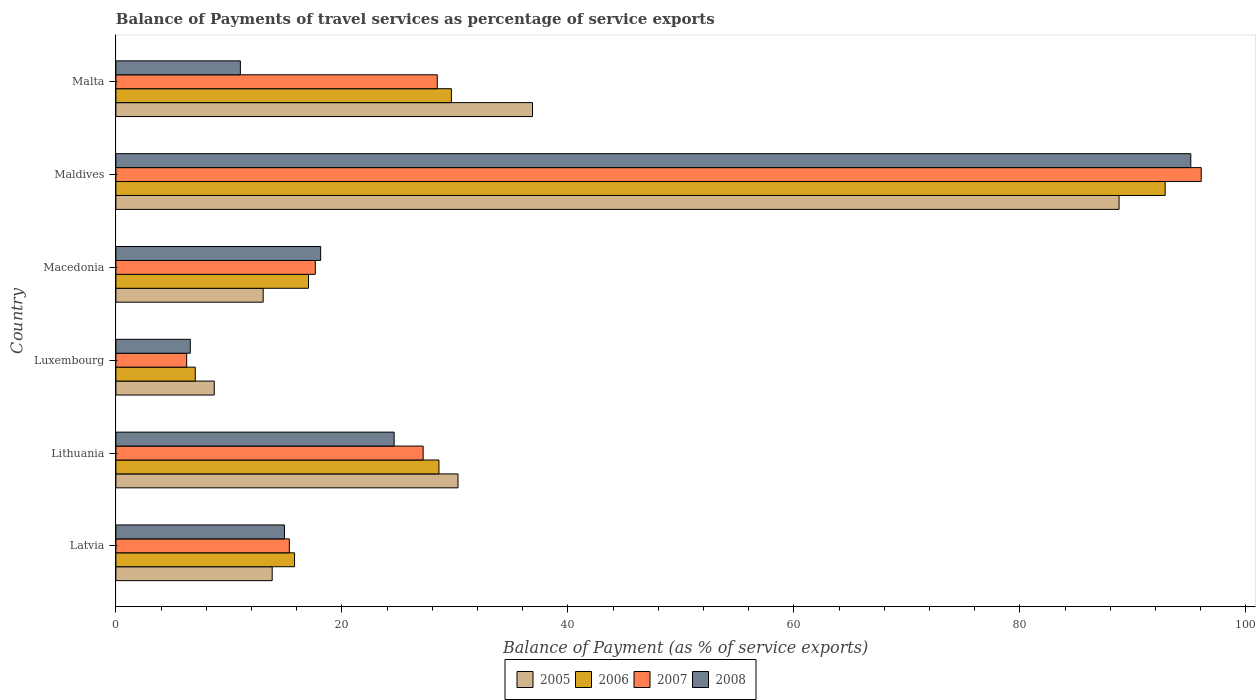What is the label of the 3rd group of bars from the top?
Your answer should be compact. Macedonia. In how many cases, is the number of bars for a given country not equal to the number of legend labels?
Offer a terse response. 0. What is the balance of payments of travel services in 2007 in Malta?
Your response must be concise. 28.44. Across all countries, what is the maximum balance of payments of travel services in 2006?
Offer a very short reply. 92.86. Across all countries, what is the minimum balance of payments of travel services in 2008?
Ensure brevity in your answer.  6.58. In which country was the balance of payments of travel services in 2005 maximum?
Your answer should be very brief. Maldives. In which country was the balance of payments of travel services in 2007 minimum?
Your response must be concise. Luxembourg. What is the total balance of payments of travel services in 2006 in the graph?
Keep it short and to the point. 191.02. What is the difference between the balance of payments of travel services in 2006 in Luxembourg and that in Macedonia?
Your answer should be very brief. -10.02. What is the difference between the balance of payments of travel services in 2006 in Maldives and the balance of payments of travel services in 2008 in Lithuania?
Keep it short and to the point. 68.23. What is the average balance of payments of travel services in 2008 per country?
Your response must be concise. 28.4. What is the difference between the balance of payments of travel services in 2005 and balance of payments of travel services in 2007 in Latvia?
Make the answer very short. -1.52. What is the ratio of the balance of payments of travel services in 2005 in Lithuania to that in Macedonia?
Make the answer very short. 2.32. Is the balance of payments of travel services in 2007 in Luxembourg less than that in Maldives?
Make the answer very short. Yes. Is the difference between the balance of payments of travel services in 2005 in Lithuania and Luxembourg greater than the difference between the balance of payments of travel services in 2007 in Lithuania and Luxembourg?
Provide a short and direct response. Yes. What is the difference between the highest and the second highest balance of payments of travel services in 2006?
Ensure brevity in your answer.  63.17. What is the difference between the highest and the lowest balance of payments of travel services in 2008?
Give a very brief answer. 88.54. Is the sum of the balance of payments of travel services in 2008 in Maldives and Malta greater than the maximum balance of payments of travel services in 2007 across all countries?
Provide a short and direct response. Yes. Is it the case that in every country, the sum of the balance of payments of travel services in 2005 and balance of payments of travel services in 2008 is greater than the sum of balance of payments of travel services in 2006 and balance of payments of travel services in 2007?
Your response must be concise. No. Is it the case that in every country, the sum of the balance of payments of travel services in 2007 and balance of payments of travel services in 2005 is greater than the balance of payments of travel services in 2006?
Provide a short and direct response. Yes. Are all the bars in the graph horizontal?
Provide a short and direct response. Yes. Are the values on the major ticks of X-axis written in scientific E-notation?
Provide a short and direct response. No. Does the graph contain any zero values?
Provide a succinct answer. No. How many legend labels are there?
Your answer should be compact. 4. What is the title of the graph?
Your response must be concise. Balance of Payments of travel services as percentage of service exports. What is the label or title of the X-axis?
Your response must be concise. Balance of Payment (as % of service exports). What is the Balance of Payment (as % of service exports) of 2005 in Latvia?
Provide a succinct answer. 13.83. What is the Balance of Payment (as % of service exports) of 2006 in Latvia?
Keep it short and to the point. 15.81. What is the Balance of Payment (as % of service exports) of 2007 in Latvia?
Keep it short and to the point. 15.35. What is the Balance of Payment (as % of service exports) of 2008 in Latvia?
Your answer should be compact. 14.92. What is the Balance of Payment (as % of service exports) of 2005 in Lithuania?
Ensure brevity in your answer.  30.28. What is the Balance of Payment (as % of service exports) of 2006 in Lithuania?
Make the answer very short. 28.59. What is the Balance of Payment (as % of service exports) in 2007 in Lithuania?
Your response must be concise. 27.19. What is the Balance of Payment (as % of service exports) of 2008 in Lithuania?
Offer a terse response. 24.62. What is the Balance of Payment (as % of service exports) of 2005 in Luxembourg?
Your answer should be compact. 8.7. What is the Balance of Payment (as % of service exports) in 2006 in Luxembourg?
Offer a very short reply. 7.03. What is the Balance of Payment (as % of service exports) in 2007 in Luxembourg?
Provide a succinct answer. 6.26. What is the Balance of Payment (as % of service exports) of 2008 in Luxembourg?
Make the answer very short. 6.58. What is the Balance of Payment (as % of service exports) in 2005 in Macedonia?
Keep it short and to the point. 13.03. What is the Balance of Payment (as % of service exports) in 2006 in Macedonia?
Provide a short and direct response. 17.05. What is the Balance of Payment (as % of service exports) in 2007 in Macedonia?
Offer a very short reply. 17.65. What is the Balance of Payment (as % of service exports) of 2008 in Macedonia?
Make the answer very short. 18.12. What is the Balance of Payment (as % of service exports) of 2005 in Maldives?
Your answer should be compact. 88.78. What is the Balance of Payment (as % of service exports) of 2006 in Maldives?
Give a very brief answer. 92.86. What is the Balance of Payment (as % of service exports) of 2007 in Maldives?
Keep it short and to the point. 96.05. What is the Balance of Payment (as % of service exports) of 2008 in Maldives?
Offer a terse response. 95.13. What is the Balance of Payment (as % of service exports) in 2005 in Malta?
Your answer should be compact. 36.87. What is the Balance of Payment (as % of service exports) of 2006 in Malta?
Keep it short and to the point. 29.69. What is the Balance of Payment (as % of service exports) of 2007 in Malta?
Keep it short and to the point. 28.44. What is the Balance of Payment (as % of service exports) in 2008 in Malta?
Offer a terse response. 11.02. Across all countries, what is the maximum Balance of Payment (as % of service exports) of 2005?
Keep it short and to the point. 88.78. Across all countries, what is the maximum Balance of Payment (as % of service exports) in 2006?
Offer a very short reply. 92.86. Across all countries, what is the maximum Balance of Payment (as % of service exports) in 2007?
Provide a short and direct response. 96.05. Across all countries, what is the maximum Balance of Payment (as % of service exports) of 2008?
Offer a terse response. 95.13. Across all countries, what is the minimum Balance of Payment (as % of service exports) of 2005?
Ensure brevity in your answer.  8.7. Across all countries, what is the minimum Balance of Payment (as % of service exports) of 2006?
Your answer should be compact. 7.03. Across all countries, what is the minimum Balance of Payment (as % of service exports) of 2007?
Provide a short and direct response. 6.26. Across all countries, what is the minimum Balance of Payment (as % of service exports) in 2008?
Ensure brevity in your answer.  6.58. What is the total Balance of Payment (as % of service exports) in 2005 in the graph?
Offer a terse response. 191.49. What is the total Balance of Payment (as % of service exports) of 2006 in the graph?
Ensure brevity in your answer.  191.02. What is the total Balance of Payment (as % of service exports) of 2007 in the graph?
Offer a terse response. 190.94. What is the total Balance of Payment (as % of service exports) of 2008 in the graph?
Provide a succinct answer. 170.39. What is the difference between the Balance of Payment (as % of service exports) of 2005 in Latvia and that in Lithuania?
Ensure brevity in your answer.  -16.44. What is the difference between the Balance of Payment (as % of service exports) of 2006 in Latvia and that in Lithuania?
Your answer should be compact. -12.78. What is the difference between the Balance of Payment (as % of service exports) in 2007 in Latvia and that in Lithuania?
Make the answer very short. -11.84. What is the difference between the Balance of Payment (as % of service exports) of 2008 in Latvia and that in Lithuania?
Give a very brief answer. -9.7. What is the difference between the Balance of Payment (as % of service exports) in 2005 in Latvia and that in Luxembourg?
Ensure brevity in your answer.  5.13. What is the difference between the Balance of Payment (as % of service exports) of 2006 in Latvia and that in Luxembourg?
Provide a short and direct response. 8.78. What is the difference between the Balance of Payment (as % of service exports) in 2007 in Latvia and that in Luxembourg?
Provide a succinct answer. 9.09. What is the difference between the Balance of Payment (as % of service exports) in 2008 in Latvia and that in Luxembourg?
Provide a short and direct response. 8.34. What is the difference between the Balance of Payment (as % of service exports) of 2005 in Latvia and that in Macedonia?
Ensure brevity in your answer.  0.8. What is the difference between the Balance of Payment (as % of service exports) of 2006 in Latvia and that in Macedonia?
Provide a short and direct response. -1.24. What is the difference between the Balance of Payment (as % of service exports) of 2007 in Latvia and that in Macedonia?
Offer a very short reply. -2.3. What is the difference between the Balance of Payment (as % of service exports) in 2008 in Latvia and that in Macedonia?
Your answer should be very brief. -3.2. What is the difference between the Balance of Payment (as % of service exports) of 2005 in Latvia and that in Maldives?
Keep it short and to the point. -74.95. What is the difference between the Balance of Payment (as % of service exports) in 2006 in Latvia and that in Maldives?
Ensure brevity in your answer.  -77.05. What is the difference between the Balance of Payment (as % of service exports) in 2007 in Latvia and that in Maldives?
Your answer should be very brief. -80.7. What is the difference between the Balance of Payment (as % of service exports) in 2008 in Latvia and that in Maldives?
Provide a succinct answer. -80.2. What is the difference between the Balance of Payment (as % of service exports) in 2005 in Latvia and that in Malta?
Give a very brief answer. -23.04. What is the difference between the Balance of Payment (as % of service exports) of 2006 in Latvia and that in Malta?
Your response must be concise. -13.88. What is the difference between the Balance of Payment (as % of service exports) of 2007 in Latvia and that in Malta?
Make the answer very short. -13.09. What is the difference between the Balance of Payment (as % of service exports) of 2008 in Latvia and that in Malta?
Your answer should be very brief. 3.9. What is the difference between the Balance of Payment (as % of service exports) in 2005 in Lithuania and that in Luxembourg?
Your answer should be very brief. 21.57. What is the difference between the Balance of Payment (as % of service exports) of 2006 in Lithuania and that in Luxembourg?
Offer a terse response. 21.56. What is the difference between the Balance of Payment (as % of service exports) of 2007 in Lithuania and that in Luxembourg?
Your response must be concise. 20.93. What is the difference between the Balance of Payment (as % of service exports) in 2008 in Lithuania and that in Luxembourg?
Your answer should be very brief. 18.04. What is the difference between the Balance of Payment (as % of service exports) in 2005 in Lithuania and that in Macedonia?
Provide a succinct answer. 17.24. What is the difference between the Balance of Payment (as % of service exports) of 2006 in Lithuania and that in Macedonia?
Keep it short and to the point. 11.54. What is the difference between the Balance of Payment (as % of service exports) of 2007 in Lithuania and that in Macedonia?
Give a very brief answer. 9.54. What is the difference between the Balance of Payment (as % of service exports) of 2008 in Lithuania and that in Macedonia?
Your answer should be very brief. 6.5. What is the difference between the Balance of Payment (as % of service exports) of 2005 in Lithuania and that in Maldives?
Provide a succinct answer. -58.5. What is the difference between the Balance of Payment (as % of service exports) of 2006 in Lithuania and that in Maldives?
Give a very brief answer. -64.27. What is the difference between the Balance of Payment (as % of service exports) in 2007 in Lithuania and that in Maldives?
Ensure brevity in your answer.  -68.86. What is the difference between the Balance of Payment (as % of service exports) of 2008 in Lithuania and that in Maldives?
Offer a terse response. -70.5. What is the difference between the Balance of Payment (as % of service exports) in 2005 in Lithuania and that in Malta?
Give a very brief answer. -6.59. What is the difference between the Balance of Payment (as % of service exports) in 2006 in Lithuania and that in Malta?
Your response must be concise. -1.1. What is the difference between the Balance of Payment (as % of service exports) of 2007 in Lithuania and that in Malta?
Give a very brief answer. -1.25. What is the difference between the Balance of Payment (as % of service exports) of 2008 in Lithuania and that in Malta?
Ensure brevity in your answer.  13.61. What is the difference between the Balance of Payment (as % of service exports) of 2005 in Luxembourg and that in Macedonia?
Your response must be concise. -4.33. What is the difference between the Balance of Payment (as % of service exports) in 2006 in Luxembourg and that in Macedonia?
Your answer should be compact. -10.02. What is the difference between the Balance of Payment (as % of service exports) of 2007 in Luxembourg and that in Macedonia?
Your answer should be compact. -11.38. What is the difference between the Balance of Payment (as % of service exports) in 2008 in Luxembourg and that in Macedonia?
Your answer should be very brief. -11.54. What is the difference between the Balance of Payment (as % of service exports) of 2005 in Luxembourg and that in Maldives?
Your answer should be compact. -80.07. What is the difference between the Balance of Payment (as % of service exports) in 2006 in Luxembourg and that in Maldives?
Your answer should be compact. -85.83. What is the difference between the Balance of Payment (as % of service exports) of 2007 in Luxembourg and that in Maldives?
Provide a short and direct response. -89.78. What is the difference between the Balance of Payment (as % of service exports) in 2008 in Luxembourg and that in Maldives?
Ensure brevity in your answer.  -88.54. What is the difference between the Balance of Payment (as % of service exports) of 2005 in Luxembourg and that in Malta?
Give a very brief answer. -28.16. What is the difference between the Balance of Payment (as % of service exports) in 2006 in Luxembourg and that in Malta?
Keep it short and to the point. -22.66. What is the difference between the Balance of Payment (as % of service exports) of 2007 in Luxembourg and that in Malta?
Keep it short and to the point. -22.18. What is the difference between the Balance of Payment (as % of service exports) in 2008 in Luxembourg and that in Malta?
Offer a very short reply. -4.43. What is the difference between the Balance of Payment (as % of service exports) of 2005 in Macedonia and that in Maldives?
Offer a terse response. -75.74. What is the difference between the Balance of Payment (as % of service exports) of 2006 in Macedonia and that in Maldives?
Offer a very short reply. -75.81. What is the difference between the Balance of Payment (as % of service exports) in 2007 in Macedonia and that in Maldives?
Give a very brief answer. -78.4. What is the difference between the Balance of Payment (as % of service exports) in 2008 in Macedonia and that in Maldives?
Make the answer very short. -77. What is the difference between the Balance of Payment (as % of service exports) of 2005 in Macedonia and that in Malta?
Your answer should be compact. -23.83. What is the difference between the Balance of Payment (as % of service exports) in 2006 in Macedonia and that in Malta?
Give a very brief answer. -12.64. What is the difference between the Balance of Payment (as % of service exports) in 2007 in Macedonia and that in Malta?
Provide a short and direct response. -10.79. What is the difference between the Balance of Payment (as % of service exports) of 2008 in Macedonia and that in Malta?
Give a very brief answer. 7.11. What is the difference between the Balance of Payment (as % of service exports) in 2005 in Maldives and that in Malta?
Provide a short and direct response. 51.91. What is the difference between the Balance of Payment (as % of service exports) in 2006 in Maldives and that in Malta?
Your answer should be very brief. 63.17. What is the difference between the Balance of Payment (as % of service exports) in 2007 in Maldives and that in Malta?
Keep it short and to the point. 67.61. What is the difference between the Balance of Payment (as % of service exports) of 2008 in Maldives and that in Malta?
Provide a short and direct response. 84.11. What is the difference between the Balance of Payment (as % of service exports) of 2005 in Latvia and the Balance of Payment (as % of service exports) of 2006 in Lithuania?
Offer a terse response. -14.76. What is the difference between the Balance of Payment (as % of service exports) in 2005 in Latvia and the Balance of Payment (as % of service exports) in 2007 in Lithuania?
Ensure brevity in your answer.  -13.36. What is the difference between the Balance of Payment (as % of service exports) of 2005 in Latvia and the Balance of Payment (as % of service exports) of 2008 in Lithuania?
Your answer should be compact. -10.79. What is the difference between the Balance of Payment (as % of service exports) of 2006 in Latvia and the Balance of Payment (as % of service exports) of 2007 in Lithuania?
Offer a very short reply. -11.38. What is the difference between the Balance of Payment (as % of service exports) in 2006 in Latvia and the Balance of Payment (as % of service exports) in 2008 in Lithuania?
Offer a terse response. -8.81. What is the difference between the Balance of Payment (as % of service exports) of 2007 in Latvia and the Balance of Payment (as % of service exports) of 2008 in Lithuania?
Ensure brevity in your answer.  -9.27. What is the difference between the Balance of Payment (as % of service exports) in 2005 in Latvia and the Balance of Payment (as % of service exports) in 2006 in Luxembourg?
Provide a succinct answer. 6.81. What is the difference between the Balance of Payment (as % of service exports) in 2005 in Latvia and the Balance of Payment (as % of service exports) in 2007 in Luxembourg?
Give a very brief answer. 7.57. What is the difference between the Balance of Payment (as % of service exports) in 2005 in Latvia and the Balance of Payment (as % of service exports) in 2008 in Luxembourg?
Keep it short and to the point. 7.25. What is the difference between the Balance of Payment (as % of service exports) in 2006 in Latvia and the Balance of Payment (as % of service exports) in 2007 in Luxembourg?
Make the answer very short. 9.55. What is the difference between the Balance of Payment (as % of service exports) in 2006 in Latvia and the Balance of Payment (as % of service exports) in 2008 in Luxembourg?
Provide a succinct answer. 9.23. What is the difference between the Balance of Payment (as % of service exports) in 2007 in Latvia and the Balance of Payment (as % of service exports) in 2008 in Luxembourg?
Offer a terse response. 8.77. What is the difference between the Balance of Payment (as % of service exports) in 2005 in Latvia and the Balance of Payment (as % of service exports) in 2006 in Macedonia?
Your answer should be very brief. -3.21. What is the difference between the Balance of Payment (as % of service exports) of 2005 in Latvia and the Balance of Payment (as % of service exports) of 2007 in Macedonia?
Make the answer very short. -3.82. What is the difference between the Balance of Payment (as % of service exports) in 2005 in Latvia and the Balance of Payment (as % of service exports) in 2008 in Macedonia?
Provide a succinct answer. -4.29. What is the difference between the Balance of Payment (as % of service exports) in 2006 in Latvia and the Balance of Payment (as % of service exports) in 2007 in Macedonia?
Your answer should be very brief. -1.84. What is the difference between the Balance of Payment (as % of service exports) in 2006 in Latvia and the Balance of Payment (as % of service exports) in 2008 in Macedonia?
Offer a terse response. -2.31. What is the difference between the Balance of Payment (as % of service exports) in 2007 in Latvia and the Balance of Payment (as % of service exports) in 2008 in Macedonia?
Your response must be concise. -2.77. What is the difference between the Balance of Payment (as % of service exports) of 2005 in Latvia and the Balance of Payment (as % of service exports) of 2006 in Maldives?
Provide a short and direct response. -79.03. What is the difference between the Balance of Payment (as % of service exports) in 2005 in Latvia and the Balance of Payment (as % of service exports) in 2007 in Maldives?
Your response must be concise. -82.22. What is the difference between the Balance of Payment (as % of service exports) in 2005 in Latvia and the Balance of Payment (as % of service exports) in 2008 in Maldives?
Your answer should be compact. -81.29. What is the difference between the Balance of Payment (as % of service exports) of 2006 in Latvia and the Balance of Payment (as % of service exports) of 2007 in Maldives?
Keep it short and to the point. -80.24. What is the difference between the Balance of Payment (as % of service exports) of 2006 in Latvia and the Balance of Payment (as % of service exports) of 2008 in Maldives?
Your answer should be very brief. -79.31. What is the difference between the Balance of Payment (as % of service exports) in 2007 in Latvia and the Balance of Payment (as % of service exports) in 2008 in Maldives?
Your answer should be very brief. -79.77. What is the difference between the Balance of Payment (as % of service exports) in 2005 in Latvia and the Balance of Payment (as % of service exports) in 2006 in Malta?
Keep it short and to the point. -15.86. What is the difference between the Balance of Payment (as % of service exports) of 2005 in Latvia and the Balance of Payment (as % of service exports) of 2007 in Malta?
Your answer should be compact. -14.61. What is the difference between the Balance of Payment (as % of service exports) of 2005 in Latvia and the Balance of Payment (as % of service exports) of 2008 in Malta?
Give a very brief answer. 2.82. What is the difference between the Balance of Payment (as % of service exports) of 2006 in Latvia and the Balance of Payment (as % of service exports) of 2007 in Malta?
Your response must be concise. -12.63. What is the difference between the Balance of Payment (as % of service exports) in 2006 in Latvia and the Balance of Payment (as % of service exports) in 2008 in Malta?
Give a very brief answer. 4.79. What is the difference between the Balance of Payment (as % of service exports) of 2007 in Latvia and the Balance of Payment (as % of service exports) of 2008 in Malta?
Ensure brevity in your answer.  4.33. What is the difference between the Balance of Payment (as % of service exports) in 2005 in Lithuania and the Balance of Payment (as % of service exports) in 2006 in Luxembourg?
Keep it short and to the point. 23.25. What is the difference between the Balance of Payment (as % of service exports) in 2005 in Lithuania and the Balance of Payment (as % of service exports) in 2007 in Luxembourg?
Provide a succinct answer. 24.01. What is the difference between the Balance of Payment (as % of service exports) in 2005 in Lithuania and the Balance of Payment (as % of service exports) in 2008 in Luxembourg?
Your response must be concise. 23.69. What is the difference between the Balance of Payment (as % of service exports) in 2006 in Lithuania and the Balance of Payment (as % of service exports) in 2007 in Luxembourg?
Keep it short and to the point. 22.32. What is the difference between the Balance of Payment (as % of service exports) of 2006 in Lithuania and the Balance of Payment (as % of service exports) of 2008 in Luxembourg?
Your answer should be compact. 22.01. What is the difference between the Balance of Payment (as % of service exports) of 2007 in Lithuania and the Balance of Payment (as % of service exports) of 2008 in Luxembourg?
Give a very brief answer. 20.61. What is the difference between the Balance of Payment (as % of service exports) of 2005 in Lithuania and the Balance of Payment (as % of service exports) of 2006 in Macedonia?
Keep it short and to the point. 13.23. What is the difference between the Balance of Payment (as % of service exports) in 2005 in Lithuania and the Balance of Payment (as % of service exports) in 2007 in Macedonia?
Give a very brief answer. 12.63. What is the difference between the Balance of Payment (as % of service exports) in 2005 in Lithuania and the Balance of Payment (as % of service exports) in 2008 in Macedonia?
Give a very brief answer. 12.15. What is the difference between the Balance of Payment (as % of service exports) of 2006 in Lithuania and the Balance of Payment (as % of service exports) of 2007 in Macedonia?
Give a very brief answer. 10.94. What is the difference between the Balance of Payment (as % of service exports) of 2006 in Lithuania and the Balance of Payment (as % of service exports) of 2008 in Macedonia?
Make the answer very short. 10.47. What is the difference between the Balance of Payment (as % of service exports) in 2007 in Lithuania and the Balance of Payment (as % of service exports) in 2008 in Macedonia?
Your answer should be compact. 9.07. What is the difference between the Balance of Payment (as % of service exports) of 2005 in Lithuania and the Balance of Payment (as % of service exports) of 2006 in Maldives?
Offer a terse response. -62.58. What is the difference between the Balance of Payment (as % of service exports) in 2005 in Lithuania and the Balance of Payment (as % of service exports) in 2007 in Maldives?
Your answer should be compact. -65.77. What is the difference between the Balance of Payment (as % of service exports) in 2005 in Lithuania and the Balance of Payment (as % of service exports) in 2008 in Maldives?
Your answer should be very brief. -64.85. What is the difference between the Balance of Payment (as % of service exports) of 2006 in Lithuania and the Balance of Payment (as % of service exports) of 2007 in Maldives?
Provide a succinct answer. -67.46. What is the difference between the Balance of Payment (as % of service exports) of 2006 in Lithuania and the Balance of Payment (as % of service exports) of 2008 in Maldives?
Ensure brevity in your answer.  -66.54. What is the difference between the Balance of Payment (as % of service exports) of 2007 in Lithuania and the Balance of Payment (as % of service exports) of 2008 in Maldives?
Provide a short and direct response. -67.93. What is the difference between the Balance of Payment (as % of service exports) in 2005 in Lithuania and the Balance of Payment (as % of service exports) in 2006 in Malta?
Keep it short and to the point. 0.58. What is the difference between the Balance of Payment (as % of service exports) of 2005 in Lithuania and the Balance of Payment (as % of service exports) of 2007 in Malta?
Your answer should be very brief. 1.83. What is the difference between the Balance of Payment (as % of service exports) in 2005 in Lithuania and the Balance of Payment (as % of service exports) in 2008 in Malta?
Offer a very short reply. 19.26. What is the difference between the Balance of Payment (as % of service exports) in 2006 in Lithuania and the Balance of Payment (as % of service exports) in 2007 in Malta?
Your answer should be compact. 0.15. What is the difference between the Balance of Payment (as % of service exports) in 2006 in Lithuania and the Balance of Payment (as % of service exports) in 2008 in Malta?
Ensure brevity in your answer.  17.57. What is the difference between the Balance of Payment (as % of service exports) of 2007 in Lithuania and the Balance of Payment (as % of service exports) of 2008 in Malta?
Give a very brief answer. 16.18. What is the difference between the Balance of Payment (as % of service exports) in 2005 in Luxembourg and the Balance of Payment (as % of service exports) in 2006 in Macedonia?
Offer a very short reply. -8.34. What is the difference between the Balance of Payment (as % of service exports) in 2005 in Luxembourg and the Balance of Payment (as % of service exports) in 2007 in Macedonia?
Offer a terse response. -8.94. What is the difference between the Balance of Payment (as % of service exports) in 2005 in Luxembourg and the Balance of Payment (as % of service exports) in 2008 in Macedonia?
Offer a very short reply. -9.42. What is the difference between the Balance of Payment (as % of service exports) of 2006 in Luxembourg and the Balance of Payment (as % of service exports) of 2007 in Macedonia?
Offer a terse response. -10.62. What is the difference between the Balance of Payment (as % of service exports) in 2006 in Luxembourg and the Balance of Payment (as % of service exports) in 2008 in Macedonia?
Give a very brief answer. -11.09. What is the difference between the Balance of Payment (as % of service exports) in 2007 in Luxembourg and the Balance of Payment (as % of service exports) in 2008 in Macedonia?
Keep it short and to the point. -11.86. What is the difference between the Balance of Payment (as % of service exports) in 2005 in Luxembourg and the Balance of Payment (as % of service exports) in 2006 in Maldives?
Ensure brevity in your answer.  -84.15. What is the difference between the Balance of Payment (as % of service exports) in 2005 in Luxembourg and the Balance of Payment (as % of service exports) in 2007 in Maldives?
Give a very brief answer. -87.34. What is the difference between the Balance of Payment (as % of service exports) in 2005 in Luxembourg and the Balance of Payment (as % of service exports) in 2008 in Maldives?
Ensure brevity in your answer.  -86.42. What is the difference between the Balance of Payment (as % of service exports) of 2006 in Luxembourg and the Balance of Payment (as % of service exports) of 2007 in Maldives?
Give a very brief answer. -89.02. What is the difference between the Balance of Payment (as % of service exports) of 2006 in Luxembourg and the Balance of Payment (as % of service exports) of 2008 in Maldives?
Your answer should be very brief. -88.1. What is the difference between the Balance of Payment (as % of service exports) of 2007 in Luxembourg and the Balance of Payment (as % of service exports) of 2008 in Maldives?
Offer a very short reply. -88.86. What is the difference between the Balance of Payment (as % of service exports) of 2005 in Luxembourg and the Balance of Payment (as % of service exports) of 2006 in Malta?
Ensure brevity in your answer.  -20.99. What is the difference between the Balance of Payment (as % of service exports) in 2005 in Luxembourg and the Balance of Payment (as % of service exports) in 2007 in Malta?
Keep it short and to the point. -19.74. What is the difference between the Balance of Payment (as % of service exports) in 2005 in Luxembourg and the Balance of Payment (as % of service exports) in 2008 in Malta?
Make the answer very short. -2.31. What is the difference between the Balance of Payment (as % of service exports) of 2006 in Luxembourg and the Balance of Payment (as % of service exports) of 2007 in Malta?
Your answer should be compact. -21.41. What is the difference between the Balance of Payment (as % of service exports) in 2006 in Luxembourg and the Balance of Payment (as % of service exports) in 2008 in Malta?
Make the answer very short. -3.99. What is the difference between the Balance of Payment (as % of service exports) of 2007 in Luxembourg and the Balance of Payment (as % of service exports) of 2008 in Malta?
Your answer should be compact. -4.75. What is the difference between the Balance of Payment (as % of service exports) of 2005 in Macedonia and the Balance of Payment (as % of service exports) of 2006 in Maldives?
Offer a very short reply. -79.82. What is the difference between the Balance of Payment (as % of service exports) of 2005 in Macedonia and the Balance of Payment (as % of service exports) of 2007 in Maldives?
Offer a very short reply. -83.01. What is the difference between the Balance of Payment (as % of service exports) in 2005 in Macedonia and the Balance of Payment (as % of service exports) in 2008 in Maldives?
Your answer should be very brief. -82.09. What is the difference between the Balance of Payment (as % of service exports) of 2006 in Macedonia and the Balance of Payment (as % of service exports) of 2007 in Maldives?
Your answer should be compact. -79. What is the difference between the Balance of Payment (as % of service exports) in 2006 in Macedonia and the Balance of Payment (as % of service exports) in 2008 in Maldives?
Give a very brief answer. -78.08. What is the difference between the Balance of Payment (as % of service exports) in 2007 in Macedonia and the Balance of Payment (as % of service exports) in 2008 in Maldives?
Make the answer very short. -77.48. What is the difference between the Balance of Payment (as % of service exports) of 2005 in Macedonia and the Balance of Payment (as % of service exports) of 2006 in Malta?
Offer a very short reply. -16.66. What is the difference between the Balance of Payment (as % of service exports) in 2005 in Macedonia and the Balance of Payment (as % of service exports) in 2007 in Malta?
Keep it short and to the point. -15.41. What is the difference between the Balance of Payment (as % of service exports) of 2005 in Macedonia and the Balance of Payment (as % of service exports) of 2008 in Malta?
Offer a very short reply. 2.02. What is the difference between the Balance of Payment (as % of service exports) of 2006 in Macedonia and the Balance of Payment (as % of service exports) of 2007 in Malta?
Your answer should be compact. -11.4. What is the difference between the Balance of Payment (as % of service exports) of 2006 in Macedonia and the Balance of Payment (as % of service exports) of 2008 in Malta?
Provide a succinct answer. 6.03. What is the difference between the Balance of Payment (as % of service exports) in 2007 in Macedonia and the Balance of Payment (as % of service exports) in 2008 in Malta?
Your response must be concise. 6.63. What is the difference between the Balance of Payment (as % of service exports) of 2005 in Maldives and the Balance of Payment (as % of service exports) of 2006 in Malta?
Your answer should be very brief. 59.09. What is the difference between the Balance of Payment (as % of service exports) in 2005 in Maldives and the Balance of Payment (as % of service exports) in 2007 in Malta?
Make the answer very short. 60.34. What is the difference between the Balance of Payment (as % of service exports) in 2005 in Maldives and the Balance of Payment (as % of service exports) in 2008 in Malta?
Make the answer very short. 77.76. What is the difference between the Balance of Payment (as % of service exports) in 2006 in Maldives and the Balance of Payment (as % of service exports) in 2007 in Malta?
Give a very brief answer. 64.42. What is the difference between the Balance of Payment (as % of service exports) in 2006 in Maldives and the Balance of Payment (as % of service exports) in 2008 in Malta?
Give a very brief answer. 81.84. What is the difference between the Balance of Payment (as % of service exports) in 2007 in Maldives and the Balance of Payment (as % of service exports) in 2008 in Malta?
Make the answer very short. 85.03. What is the average Balance of Payment (as % of service exports) in 2005 per country?
Your response must be concise. 31.91. What is the average Balance of Payment (as % of service exports) in 2006 per country?
Ensure brevity in your answer.  31.84. What is the average Balance of Payment (as % of service exports) in 2007 per country?
Keep it short and to the point. 31.82. What is the average Balance of Payment (as % of service exports) of 2008 per country?
Offer a terse response. 28.4. What is the difference between the Balance of Payment (as % of service exports) in 2005 and Balance of Payment (as % of service exports) in 2006 in Latvia?
Provide a short and direct response. -1.98. What is the difference between the Balance of Payment (as % of service exports) of 2005 and Balance of Payment (as % of service exports) of 2007 in Latvia?
Give a very brief answer. -1.52. What is the difference between the Balance of Payment (as % of service exports) of 2005 and Balance of Payment (as % of service exports) of 2008 in Latvia?
Ensure brevity in your answer.  -1.09. What is the difference between the Balance of Payment (as % of service exports) in 2006 and Balance of Payment (as % of service exports) in 2007 in Latvia?
Your answer should be very brief. 0.46. What is the difference between the Balance of Payment (as % of service exports) of 2006 and Balance of Payment (as % of service exports) of 2008 in Latvia?
Your answer should be compact. 0.89. What is the difference between the Balance of Payment (as % of service exports) in 2007 and Balance of Payment (as % of service exports) in 2008 in Latvia?
Give a very brief answer. 0.43. What is the difference between the Balance of Payment (as % of service exports) in 2005 and Balance of Payment (as % of service exports) in 2006 in Lithuania?
Your response must be concise. 1.69. What is the difference between the Balance of Payment (as % of service exports) of 2005 and Balance of Payment (as % of service exports) of 2007 in Lithuania?
Your response must be concise. 3.08. What is the difference between the Balance of Payment (as % of service exports) in 2005 and Balance of Payment (as % of service exports) in 2008 in Lithuania?
Offer a terse response. 5.65. What is the difference between the Balance of Payment (as % of service exports) in 2006 and Balance of Payment (as % of service exports) in 2007 in Lithuania?
Your answer should be very brief. 1.4. What is the difference between the Balance of Payment (as % of service exports) in 2006 and Balance of Payment (as % of service exports) in 2008 in Lithuania?
Provide a succinct answer. 3.96. What is the difference between the Balance of Payment (as % of service exports) in 2007 and Balance of Payment (as % of service exports) in 2008 in Lithuania?
Provide a short and direct response. 2.57. What is the difference between the Balance of Payment (as % of service exports) of 2005 and Balance of Payment (as % of service exports) of 2006 in Luxembourg?
Your answer should be compact. 1.68. What is the difference between the Balance of Payment (as % of service exports) in 2005 and Balance of Payment (as % of service exports) in 2007 in Luxembourg?
Provide a succinct answer. 2.44. What is the difference between the Balance of Payment (as % of service exports) in 2005 and Balance of Payment (as % of service exports) in 2008 in Luxembourg?
Ensure brevity in your answer.  2.12. What is the difference between the Balance of Payment (as % of service exports) in 2006 and Balance of Payment (as % of service exports) in 2007 in Luxembourg?
Offer a very short reply. 0.76. What is the difference between the Balance of Payment (as % of service exports) in 2006 and Balance of Payment (as % of service exports) in 2008 in Luxembourg?
Give a very brief answer. 0.44. What is the difference between the Balance of Payment (as % of service exports) of 2007 and Balance of Payment (as % of service exports) of 2008 in Luxembourg?
Offer a terse response. -0.32. What is the difference between the Balance of Payment (as % of service exports) of 2005 and Balance of Payment (as % of service exports) of 2006 in Macedonia?
Your answer should be very brief. -4.01. What is the difference between the Balance of Payment (as % of service exports) in 2005 and Balance of Payment (as % of service exports) in 2007 in Macedonia?
Offer a terse response. -4.61. What is the difference between the Balance of Payment (as % of service exports) in 2005 and Balance of Payment (as % of service exports) in 2008 in Macedonia?
Your response must be concise. -5.09. What is the difference between the Balance of Payment (as % of service exports) in 2006 and Balance of Payment (as % of service exports) in 2007 in Macedonia?
Your response must be concise. -0.6. What is the difference between the Balance of Payment (as % of service exports) of 2006 and Balance of Payment (as % of service exports) of 2008 in Macedonia?
Your answer should be very brief. -1.08. What is the difference between the Balance of Payment (as % of service exports) of 2007 and Balance of Payment (as % of service exports) of 2008 in Macedonia?
Give a very brief answer. -0.47. What is the difference between the Balance of Payment (as % of service exports) in 2005 and Balance of Payment (as % of service exports) in 2006 in Maldives?
Provide a short and direct response. -4.08. What is the difference between the Balance of Payment (as % of service exports) in 2005 and Balance of Payment (as % of service exports) in 2007 in Maldives?
Provide a short and direct response. -7.27. What is the difference between the Balance of Payment (as % of service exports) in 2005 and Balance of Payment (as % of service exports) in 2008 in Maldives?
Provide a short and direct response. -6.35. What is the difference between the Balance of Payment (as % of service exports) in 2006 and Balance of Payment (as % of service exports) in 2007 in Maldives?
Your response must be concise. -3.19. What is the difference between the Balance of Payment (as % of service exports) of 2006 and Balance of Payment (as % of service exports) of 2008 in Maldives?
Your response must be concise. -2.27. What is the difference between the Balance of Payment (as % of service exports) in 2007 and Balance of Payment (as % of service exports) in 2008 in Maldives?
Your response must be concise. 0.92. What is the difference between the Balance of Payment (as % of service exports) in 2005 and Balance of Payment (as % of service exports) in 2006 in Malta?
Make the answer very short. 7.18. What is the difference between the Balance of Payment (as % of service exports) in 2005 and Balance of Payment (as % of service exports) in 2007 in Malta?
Your answer should be compact. 8.43. What is the difference between the Balance of Payment (as % of service exports) of 2005 and Balance of Payment (as % of service exports) of 2008 in Malta?
Keep it short and to the point. 25.85. What is the difference between the Balance of Payment (as % of service exports) in 2006 and Balance of Payment (as % of service exports) in 2007 in Malta?
Offer a very short reply. 1.25. What is the difference between the Balance of Payment (as % of service exports) in 2006 and Balance of Payment (as % of service exports) in 2008 in Malta?
Make the answer very short. 18.67. What is the difference between the Balance of Payment (as % of service exports) of 2007 and Balance of Payment (as % of service exports) of 2008 in Malta?
Give a very brief answer. 17.43. What is the ratio of the Balance of Payment (as % of service exports) in 2005 in Latvia to that in Lithuania?
Offer a terse response. 0.46. What is the ratio of the Balance of Payment (as % of service exports) of 2006 in Latvia to that in Lithuania?
Make the answer very short. 0.55. What is the ratio of the Balance of Payment (as % of service exports) of 2007 in Latvia to that in Lithuania?
Provide a short and direct response. 0.56. What is the ratio of the Balance of Payment (as % of service exports) of 2008 in Latvia to that in Lithuania?
Offer a very short reply. 0.61. What is the ratio of the Balance of Payment (as % of service exports) in 2005 in Latvia to that in Luxembourg?
Make the answer very short. 1.59. What is the ratio of the Balance of Payment (as % of service exports) of 2006 in Latvia to that in Luxembourg?
Ensure brevity in your answer.  2.25. What is the ratio of the Balance of Payment (as % of service exports) in 2007 in Latvia to that in Luxembourg?
Provide a short and direct response. 2.45. What is the ratio of the Balance of Payment (as % of service exports) in 2008 in Latvia to that in Luxembourg?
Offer a very short reply. 2.27. What is the ratio of the Balance of Payment (as % of service exports) in 2005 in Latvia to that in Macedonia?
Make the answer very short. 1.06. What is the ratio of the Balance of Payment (as % of service exports) in 2006 in Latvia to that in Macedonia?
Make the answer very short. 0.93. What is the ratio of the Balance of Payment (as % of service exports) in 2007 in Latvia to that in Macedonia?
Offer a terse response. 0.87. What is the ratio of the Balance of Payment (as % of service exports) in 2008 in Latvia to that in Macedonia?
Your answer should be compact. 0.82. What is the ratio of the Balance of Payment (as % of service exports) of 2005 in Latvia to that in Maldives?
Your answer should be very brief. 0.16. What is the ratio of the Balance of Payment (as % of service exports) of 2006 in Latvia to that in Maldives?
Make the answer very short. 0.17. What is the ratio of the Balance of Payment (as % of service exports) of 2007 in Latvia to that in Maldives?
Provide a succinct answer. 0.16. What is the ratio of the Balance of Payment (as % of service exports) of 2008 in Latvia to that in Maldives?
Offer a terse response. 0.16. What is the ratio of the Balance of Payment (as % of service exports) in 2005 in Latvia to that in Malta?
Give a very brief answer. 0.38. What is the ratio of the Balance of Payment (as % of service exports) of 2006 in Latvia to that in Malta?
Give a very brief answer. 0.53. What is the ratio of the Balance of Payment (as % of service exports) in 2007 in Latvia to that in Malta?
Provide a short and direct response. 0.54. What is the ratio of the Balance of Payment (as % of service exports) of 2008 in Latvia to that in Malta?
Offer a very short reply. 1.35. What is the ratio of the Balance of Payment (as % of service exports) in 2005 in Lithuania to that in Luxembourg?
Your answer should be compact. 3.48. What is the ratio of the Balance of Payment (as % of service exports) of 2006 in Lithuania to that in Luxembourg?
Your answer should be very brief. 4.07. What is the ratio of the Balance of Payment (as % of service exports) in 2007 in Lithuania to that in Luxembourg?
Provide a succinct answer. 4.34. What is the ratio of the Balance of Payment (as % of service exports) of 2008 in Lithuania to that in Luxembourg?
Make the answer very short. 3.74. What is the ratio of the Balance of Payment (as % of service exports) in 2005 in Lithuania to that in Macedonia?
Your answer should be very brief. 2.32. What is the ratio of the Balance of Payment (as % of service exports) in 2006 in Lithuania to that in Macedonia?
Offer a very short reply. 1.68. What is the ratio of the Balance of Payment (as % of service exports) in 2007 in Lithuania to that in Macedonia?
Offer a very short reply. 1.54. What is the ratio of the Balance of Payment (as % of service exports) of 2008 in Lithuania to that in Macedonia?
Ensure brevity in your answer.  1.36. What is the ratio of the Balance of Payment (as % of service exports) of 2005 in Lithuania to that in Maldives?
Ensure brevity in your answer.  0.34. What is the ratio of the Balance of Payment (as % of service exports) in 2006 in Lithuania to that in Maldives?
Your response must be concise. 0.31. What is the ratio of the Balance of Payment (as % of service exports) of 2007 in Lithuania to that in Maldives?
Ensure brevity in your answer.  0.28. What is the ratio of the Balance of Payment (as % of service exports) of 2008 in Lithuania to that in Maldives?
Your response must be concise. 0.26. What is the ratio of the Balance of Payment (as % of service exports) in 2005 in Lithuania to that in Malta?
Offer a very short reply. 0.82. What is the ratio of the Balance of Payment (as % of service exports) in 2006 in Lithuania to that in Malta?
Make the answer very short. 0.96. What is the ratio of the Balance of Payment (as % of service exports) of 2007 in Lithuania to that in Malta?
Your answer should be compact. 0.96. What is the ratio of the Balance of Payment (as % of service exports) of 2008 in Lithuania to that in Malta?
Provide a short and direct response. 2.24. What is the ratio of the Balance of Payment (as % of service exports) in 2005 in Luxembourg to that in Macedonia?
Give a very brief answer. 0.67. What is the ratio of the Balance of Payment (as % of service exports) of 2006 in Luxembourg to that in Macedonia?
Make the answer very short. 0.41. What is the ratio of the Balance of Payment (as % of service exports) of 2007 in Luxembourg to that in Macedonia?
Your answer should be compact. 0.35. What is the ratio of the Balance of Payment (as % of service exports) of 2008 in Luxembourg to that in Macedonia?
Keep it short and to the point. 0.36. What is the ratio of the Balance of Payment (as % of service exports) of 2005 in Luxembourg to that in Maldives?
Give a very brief answer. 0.1. What is the ratio of the Balance of Payment (as % of service exports) of 2006 in Luxembourg to that in Maldives?
Provide a succinct answer. 0.08. What is the ratio of the Balance of Payment (as % of service exports) of 2007 in Luxembourg to that in Maldives?
Your answer should be very brief. 0.07. What is the ratio of the Balance of Payment (as % of service exports) in 2008 in Luxembourg to that in Maldives?
Your answer should be compact. 0.07. What is the ratio of the Balance of Payment (as % of service exports) in 2005 in Luxembourg to that in Malta?
Offer a very short reply. 0.24. What is the ratio of the Balance of Payment (as % of service exports) in 2006 in Luxembourg to that in Malta?
Keep it short and to the point. 0.24. What is the ratio of the Balance of Payment (as % of service exports) of 2007 in Luxembourg to that in Malta?
Offer a very short reply. 0.22. What is the ratio of the Balance of Payment (as % of service exports) in 2008 in Luxembourg to that in Malta?
Make the answer very short. 0.6. What is the ratio of the Balance of Payment (as % of service exports) of 2005 in Macedonia to that in Maldives?
Give a very brief answer. 0.15. What is the ratio of the Balance of Payment (as % of service exports) in 2006 in Macedonia to that in Maldives?
Offer a terse response. 0.18. What is the ratio of the Balance of Payment (as % of service exports) in 2007 in Macedonia to that in Maldives?
Your answer should be compact. 0.18. What is the ratio of the Balance of Payment (as % of service exports) in 2008 in Macedonia to that in Maldives?
Make the answer very short. 0.19. What is the ratio of the Balance of Payment (as % of service exports) of 2005 in Macedonia to that in Malta?
Make the answer very short. 0.35. What is the ratio of the Balance of Payment (as % of service exports) of 2006 in Macedonia to that in Malta?
Your answer should be compact. 0.57. What is the ratio of the Balance of Payment (as % of service exports) in 2007 in Macedonia to that in Malta?
Give a very brief answer. 0.62. What is the ratio of the Balance of Payment (as % of service exports) in 2008 in Macedonia to that in Malta?
Your answer should be compact. 1.65. What is the ratio of the Balance of Payment (as % of service exports) of 2005 in Maldives to that in Malta?
Provide a succinct answer. 2.41. What is the ratio of the Balance of Payment (as % of service exports) of 2006 in Maldives to that in Malta?
Provide a succinct answer. 3.13. What is the ratio of the Balance of Payment (as % of service exports) of 2007 in Maldives to that in Malta?
Give a very brief answer. 3.38. What is the ratio of the Balance of Payment (as % of service exports) of 2008 in Maldives to that in Malta?
Give a very brief answer. 8.64. What is the difference between the highest and the second highest Balance of Payment (as % of service exports) of 2005?
Your answer should be very brief. 51.91. What is the difference between the highest and the second highest Balance of Payment (as % of service exports) in 2006?
Make the answer very short. 63.17. What is the difference between the highest and the second highest Balance of Payment (as % of service exports) in 2007?
Make the answer very short. 67.61. What is the difference between the highest and the second highest Balance of Payment (as % of service exports) in 2008?
Make the answer very short. 70.5. What is the difference between the highest and the lowest Balance of Payment (as % of service exports) in 2005?
Offer a terse response. 80.07. What is the difference between the highest and the lowest Balance of Payment (as % of service exports) of 2006?
Ensure brevity in your answer.  85.83. What is the difference between the highest and the lowest Balance of Payment (as % of service exports) of 2007?
Offer a terse response. 89.78. What is the difference between the highest and the lowest Balance of Payment (as % of service exports) of 2008?
Provide a succinct answer. 88.54. 